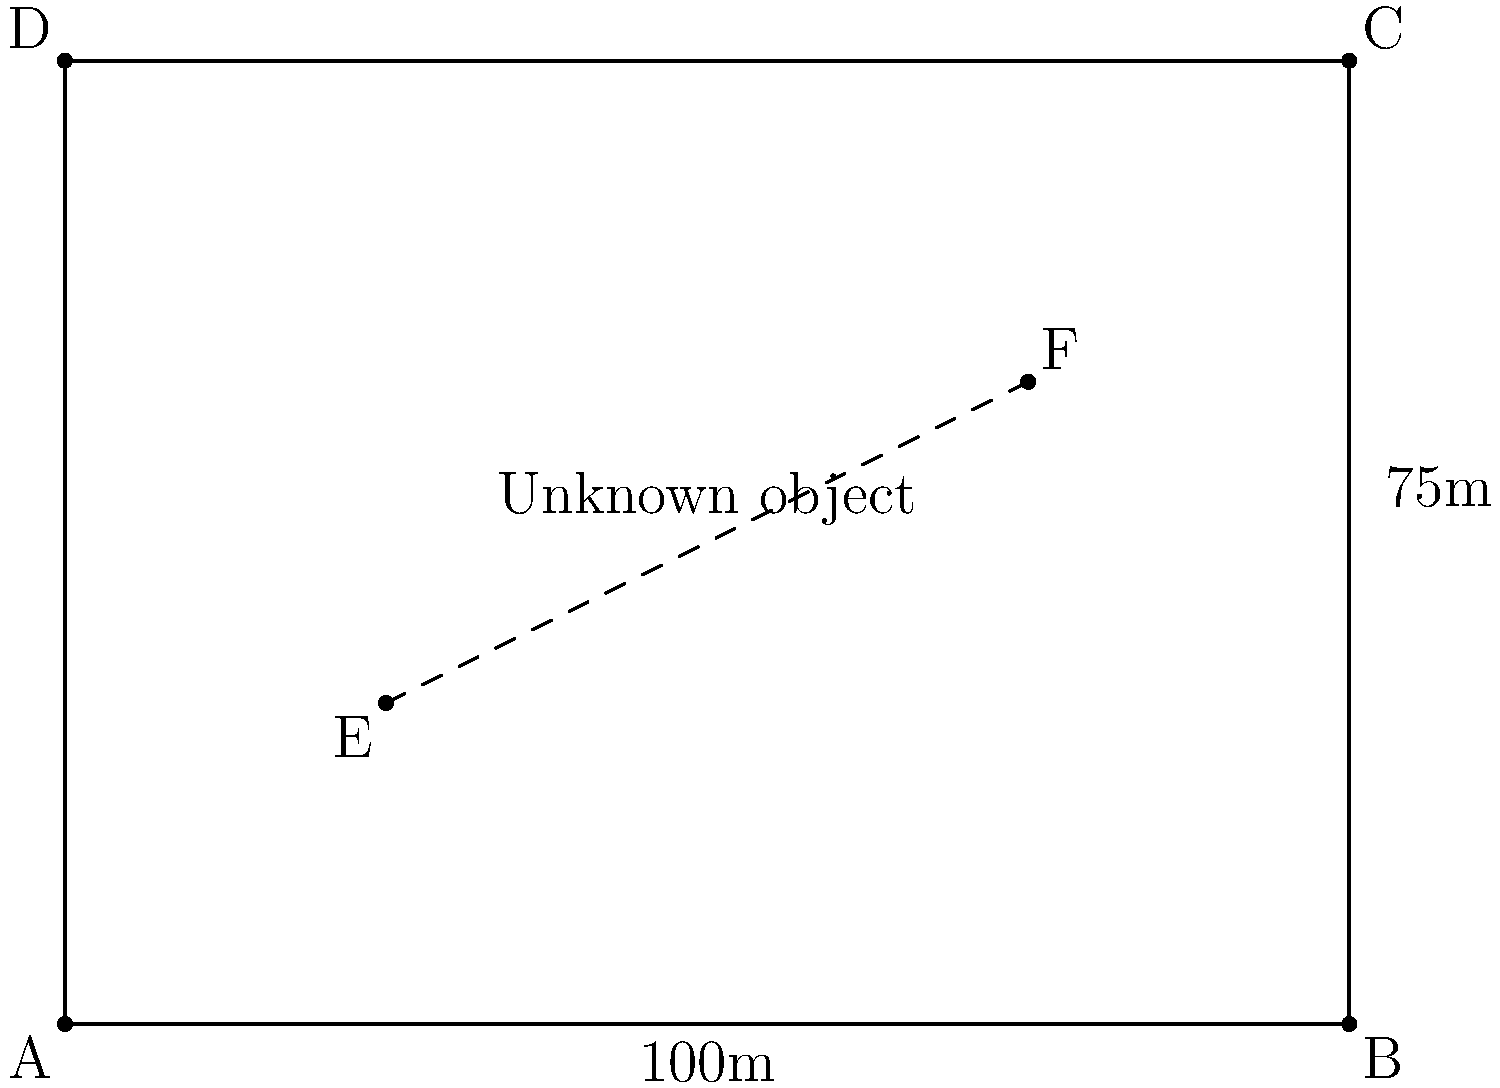In a satellite image, you observe a rectangular area ABCD with known dimensions of 100m x 75m. An unknown object is represented by the dashed line EF within this area. Given that E is located at (25m, 25m) and F is at (75m, 50m) relative to point A, estimate the length of the unknown object EF to the nearest meter. To estimate the length of the unknown object EF, we'll use the distance formula in a coordinate system. Let's approach this step-by-step:

1) First, we need to set up our coordinate system. We know that:
   - The width of the rectangle is 100m, so B is at (100, 0)
   - The height of the rectangle is 75m, so D is at (0, 75)

2) We're given the coordinates of E and F relative to A:
   - E is at (25, 25)
   - F is at (75, 50)

3) Now we can use the distance formula:
   $$d = \sqrt{(x_2-x_1)^2 + (y_2-y_1)^2}$$

4) Plugging in our values:
   $$d = \sqrt{(75-25)^2 + (50-25)^2}$$

5) Simplify:
   $$d = \sqrt{50^2 + 25^2}$$
   $$d = \sqrt{2500 + 625}$$
   $$d = \sqrt{3125}$$

6) Calculate:
   $$d \approx 55.90169943749474$$

7) Rounding to the nearest meter:
   $$d \approx 56\text{ meters}$$

Therefore, the estimated length of the unknown object EF is 56 meters.
Answer: 56 meters 